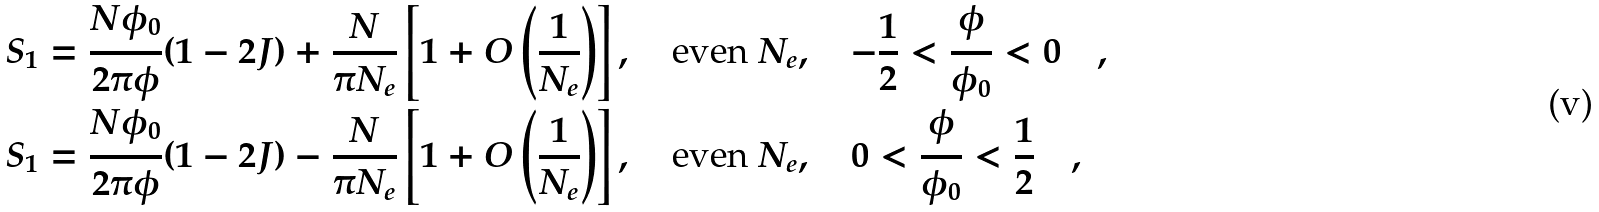<formula> <loc_0><loc_0><loc_500><loc_500>S _ { 1 } & = \frac { N \phi _ { 0 } } { 2 \pi \phi } ( 1 - 2 J ) + \frac { N } { \pi N _ { e } } \left [ 1 + O \left ( \frac { 1 } { N _ { e } } \right ) \right ] , \quad \text {even } N _ { e } , \quad - \frac { 1 } { 2 } < \frac { \phi } { \phi _ { 0 } } < 0 \quad , \\ S _ { 1 } & = \frac { N \phi _ { 0 } } { 2 \pi \phi } ( 1 - 2 J ) - \frac { N } { \pi N _ { e } } \left [ 1 + O \left ( \frac { 1 } { N _ { e } } \right ) \right ] , \quad \text {even } N _ { e } , \quad 0 < \frac { \phi } { \phi _ { 0 } } < \frac { 1 } { 2 } \quad ,</formula> 